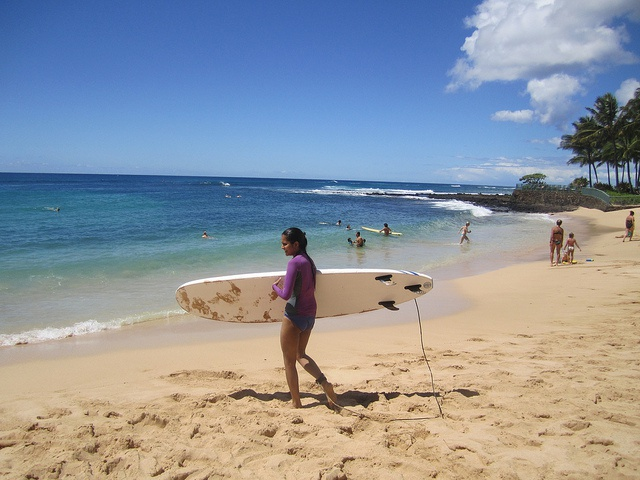Describe the objects in this image and their specific colors. I can see surfboard in blue, tan, gray, and white tones, people in blue, maroon, black, and gray tones, people in blue, maroon, brown, and black tones, people in blue, darkgray, brown, tan, and maroon tones, and people in blue, gray, black, and maroon tones in this image. 